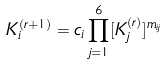Convert formula to latex. <formula><loc_0><loc_0><loc_500><loc_500>K _ { i } ^ { ( r + 1 ) } = c _ { i } \prod _ { j = 1 } ^ { 6 } [ K _ { j } ^ { ( r ) } ] ^ { { m } _ { i j } }</formula> 